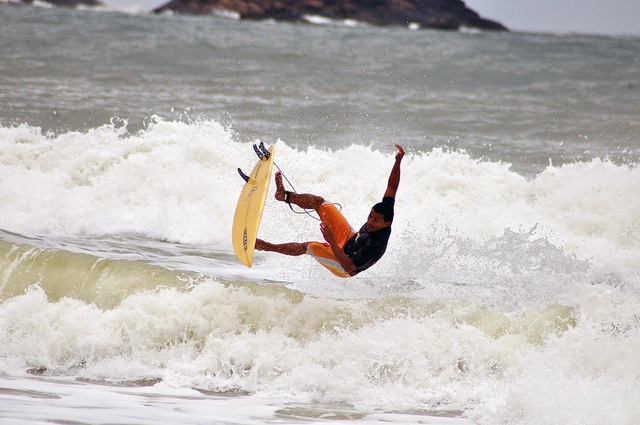Describe the objects in this image and their specific colors. I can see people in gray, maroon, black, brown, and red tones and surfboard in gray, tan, and khaki tones in this image. 